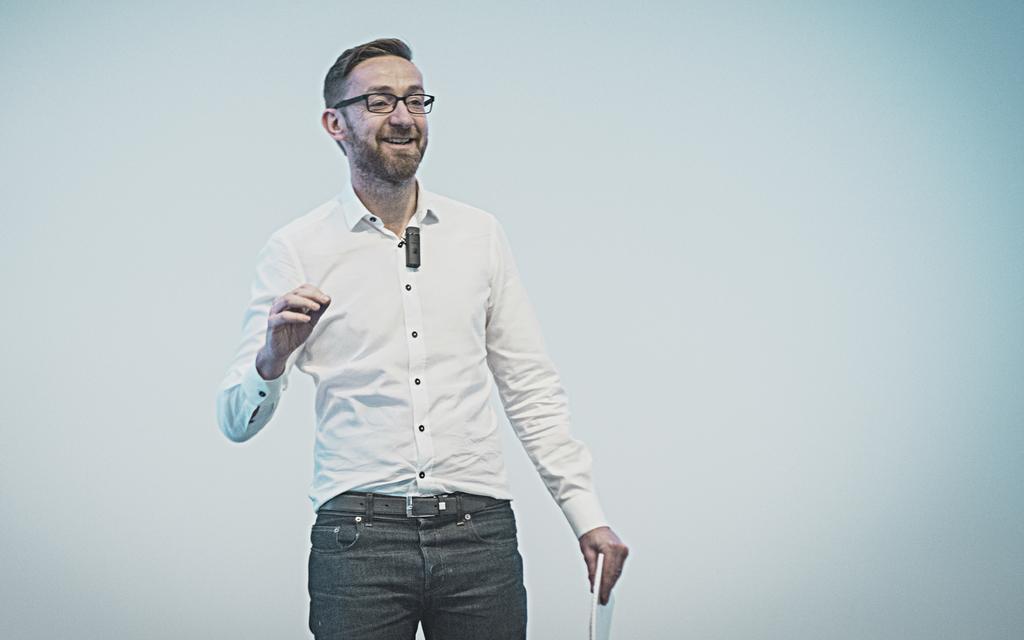In one or two sentences, can you explain what this image depicts? There is a man standing in the foreground area of the image, by holding a book in his hand. 